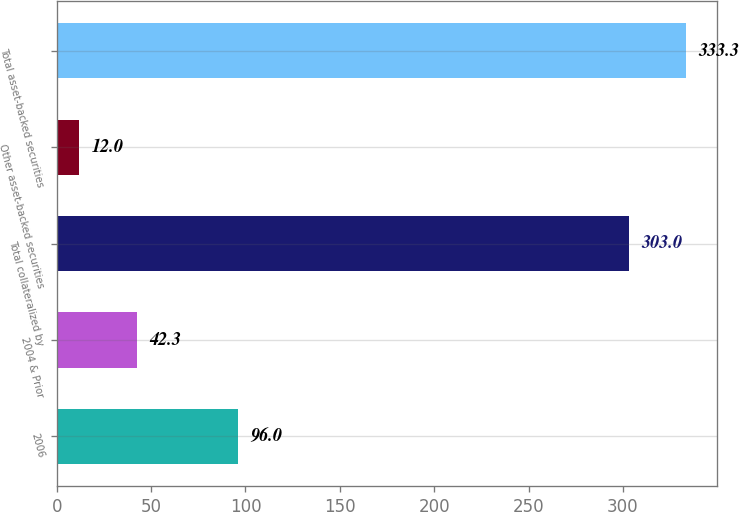Convert chart. <chart><loc_0><loc_0><loc_500><loc_500><bar_chart><fcel>2006<fcel>2004 & Prior<fcel>Total collateralized by<fcel>Other asset-backed securities<fcel>Total asset-backed securities<nl><fcel>96<fcel>42.3<fcel>303<fcel>12<fcel>333.3<nl></chart> 